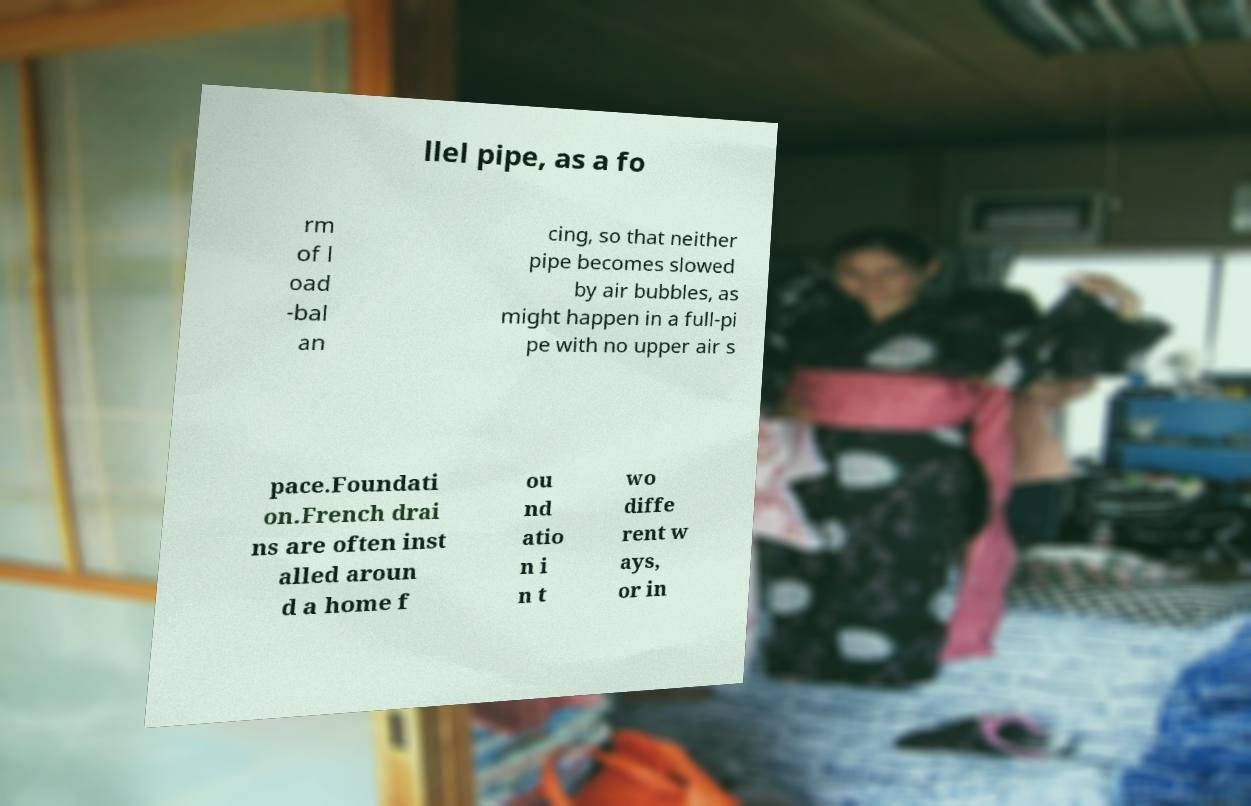Please identify and transcribe the text found in this image. llel pipe, as a fo rm of l oad -bal an cing, so that neither pipe becomes slowed by air bubbles, as might happen in a full-pi pe with no upper air s pace.Foundati on.French drai ns are often inst alled aroun d a home f ou nd atio n i n t wo diffe rent w ays, or in 